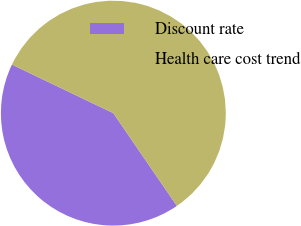<chart> <loc_0><loc_0><loc_500><loc_500><pie_chart><fcel>Discount rate<fcel>Health care cost trend<nl><fcel>41.67%<fcel>58.33%<nl></chart> 